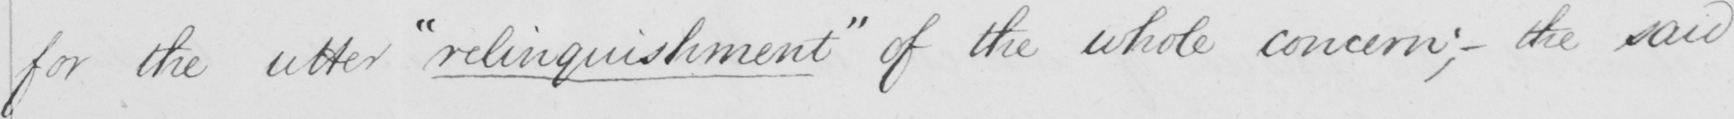What text is written in this handwritten line? for the utter  " relinquishment "  of the whole concern ;  _  the said 